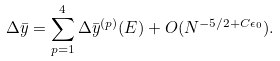Convert formula to latex. <formula><loc_0><loc_0><loc_500><loc_500>\Delta \bar { y } = \sum _ { p = 1 } ^ { 4 } \Delta \bar { y } ^ { ( p ) } ( E ) + O ( N ^ { - 5 / 2 + C \epsilon _ { 0 } } ) .</formula> 